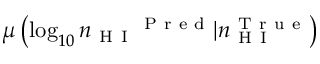Convert formula to latex. <formula><loc_0><loc_0><loc_500><loc_500>\mu \left ( \log _ { 1 0 } { n _ { H I } } ^ { P r e d } | n _ { H I } ^ { T r u e } \right )</formula> 